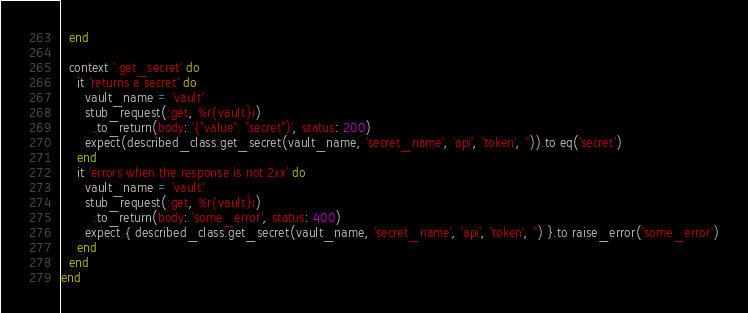<code> <loc_0><loc_0><loc_500><loc_500><_Ruby_>  end

  context '.get_secret' do
    it 'returns a secret' do
      vault_name = 'vault'
      stub_request(:get, %r{vault}i)
        .to_return(body: '{"value": "secret"}', status: 200)
      expect(described_class.get_secret(vault_name, 'secret_name', 'api', 'token', '')).to eq('secret')
    end
    it 'errors when the response is not 2xx' do
      vault_name = 'vault'
      stub_request(:get, %r{vault}i)
        .to_return(body: 'some_error', status: 400)
      expect { described_class.get_secret(vault_name, 'secret_name', 'api', 'token', '') }.to raise_error('some_error')
    end
  end
end
</code> 